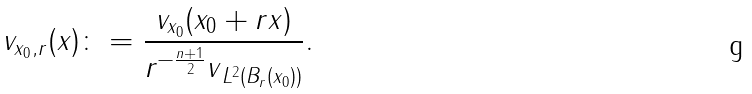Convert formula to latex. <formula><loc_0><loc_0><loc_500><loc_500>v _ { x _ { 0 } , r } ( x ) \colon = \frac { v _ { x _ { 0 } } ( x _ { 0 } + r x ) } { r ^ { - \frac { n + 1 } { 2 } } \| v \| _ { L ^ { 2 } ( B _ { r } ( x _ { 0 } ) ) } } .</formula> 